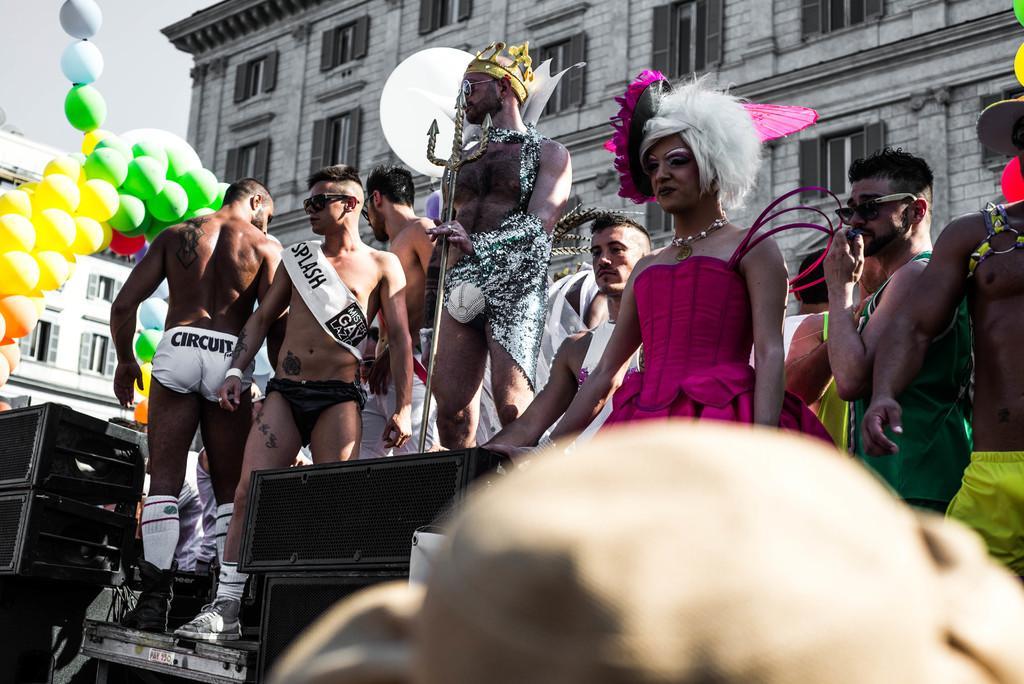Could you give a brief overview of what you see in this image? In this image people are standing on the stage. In front of them there are speakers. At the back side there are buildings. At the left side of the image there are balloons. At the top there is sky. 